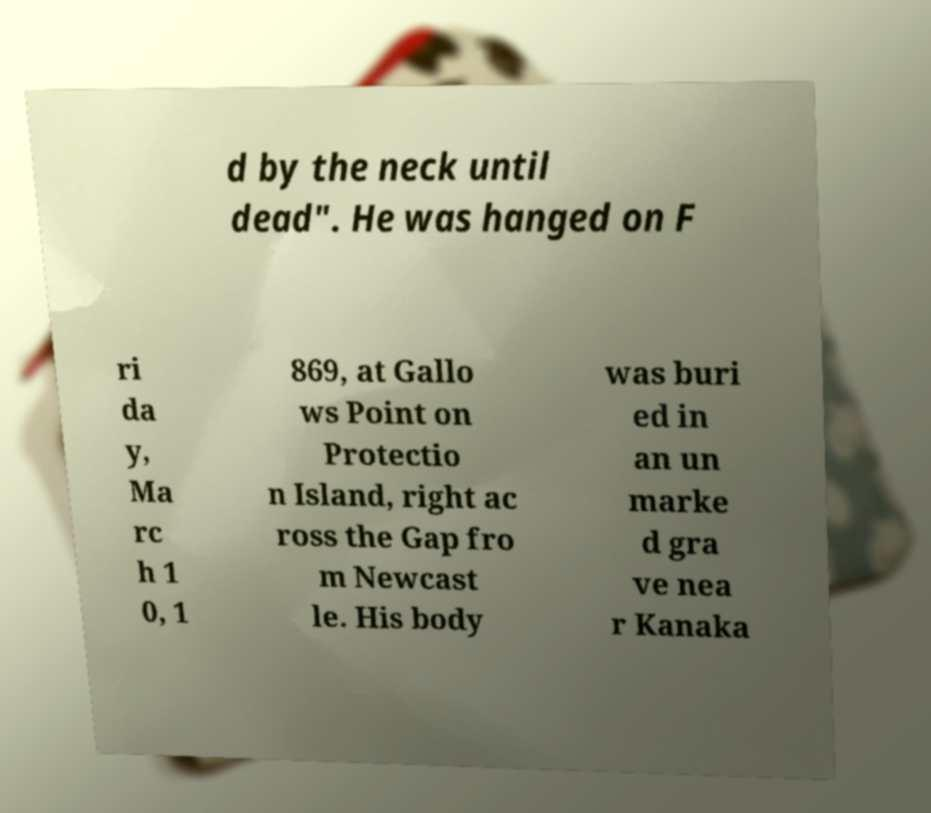Could you extract and type out the text from this image? d by the neck until dead". He was hanged on F ri da y, Ma rc h 1 0, 1 869, at Gallo ws Point on Protectio n Island, right ac ross the Gap fro m Newcast le. His body was buri ed in an un marke d gra ve nea r Kanaka 